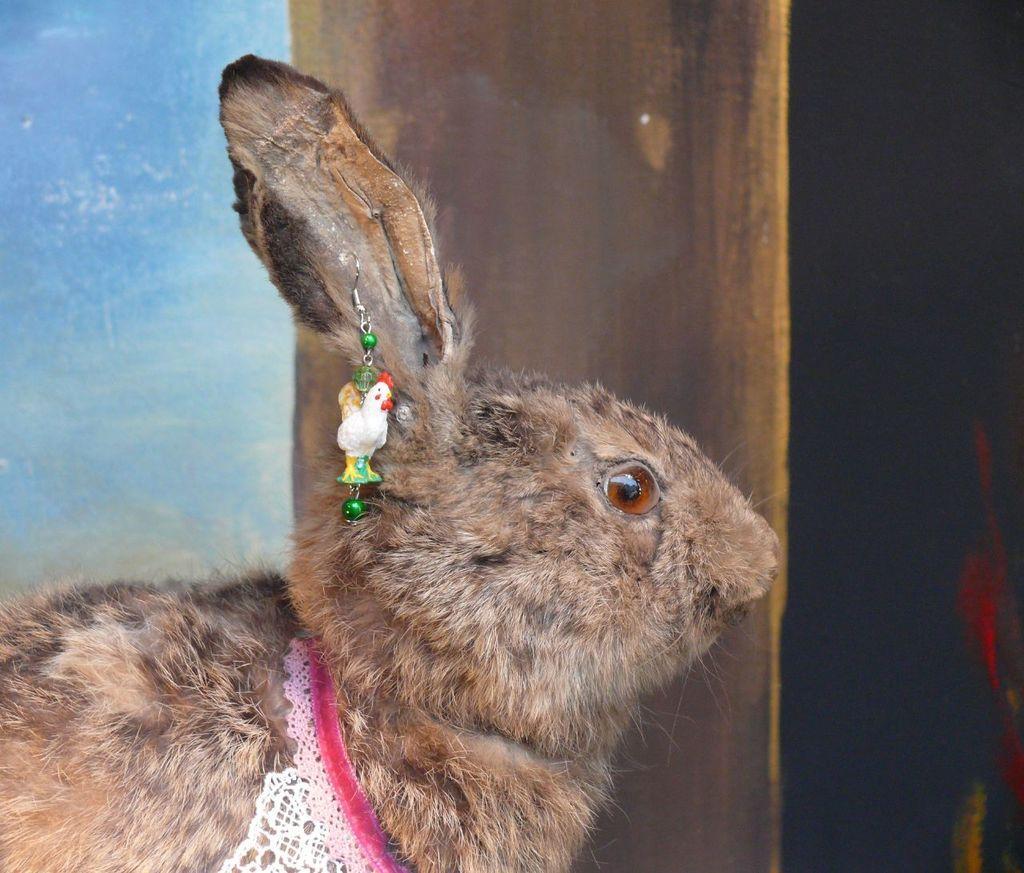Could you give a brief overview of what you see in this image? In this image, we can see a brown color rabbit. 